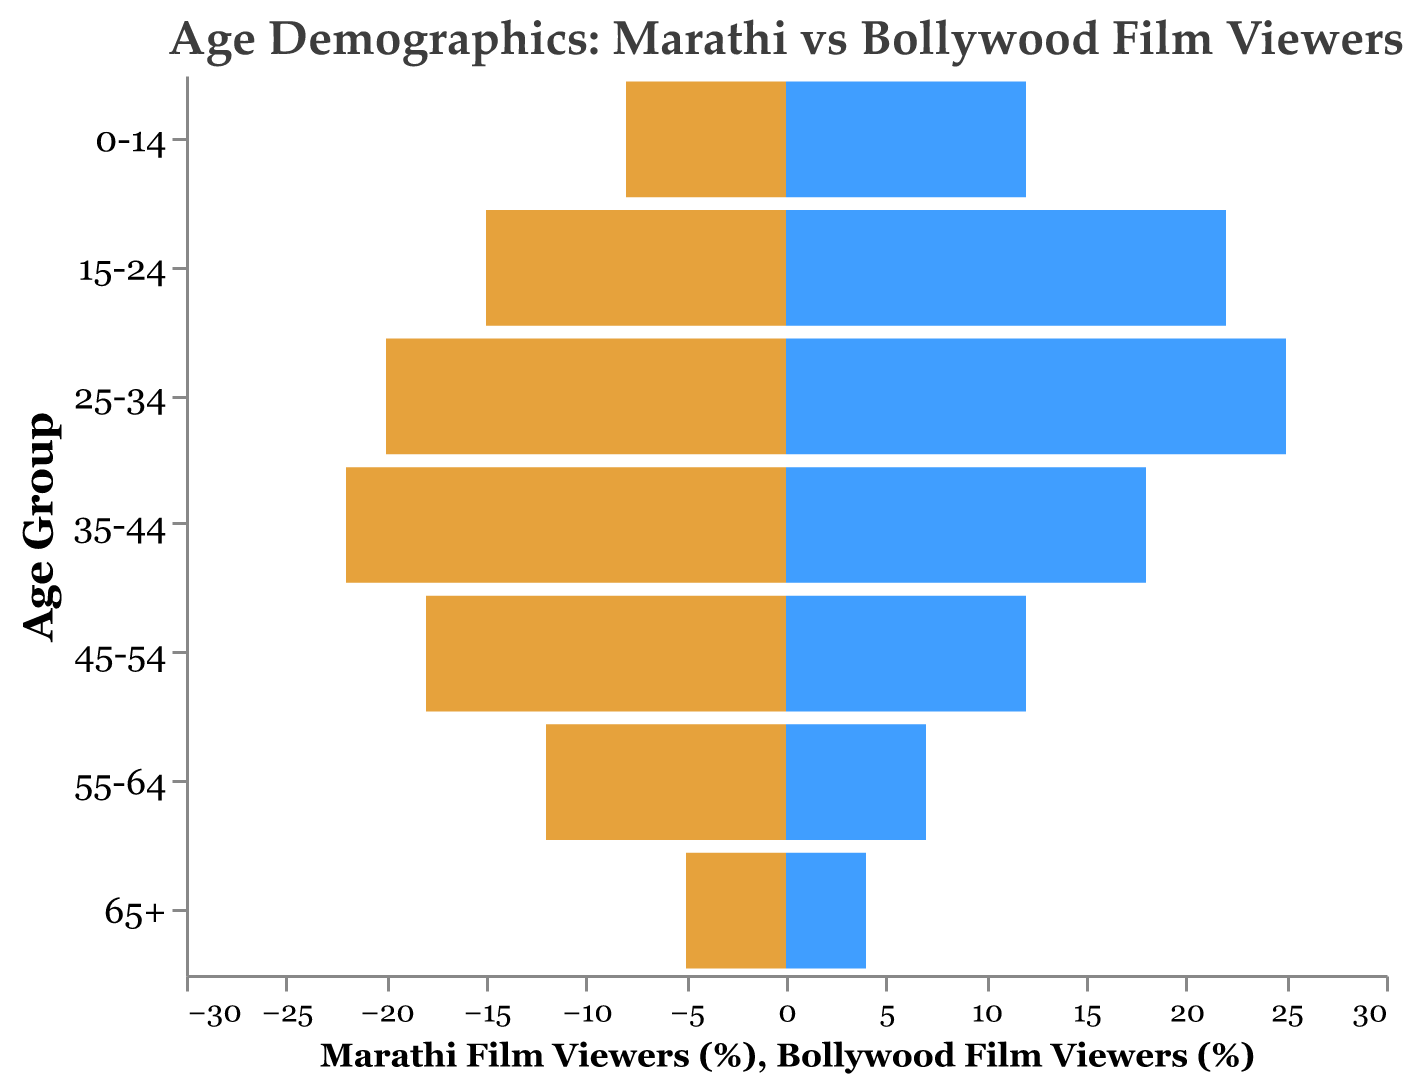What is the title of the figure? The title of the figure is displayed prominently at the top, indicating the comparison of age demographics between Marathi and Bollywood film viewers.
Answer: Age Demographics: Marathi vs Bollywood Film Viewers Which age group has the highest percentage of Marathi film viewers? Look for the largest bar on the left side, representing Marathi film viewers. The group with the largest absolute value on this side is the 35-44 age group.
Answer: 35-44 Which age group has the lowest percentage of Bollywood film viewers? Find the smallest bar on the right side, representing Bollywood film viewers. The smallest bar corresponds to the 65+ age group.
Answer: 65+ How does the percentage of viewers in the 0-14 age group compare between Marathi and Bollywood films? Compare the bars for the 0-14 age group on both sides. The Bollywood bar (right side) is longer than the Marathi bar (left side).
Answer: Bollywood has a higher percentage (12% vs 8%) Which age group shows a higher percentage of Marathi film viewers compared to Bollywood film viewers? Look for age groups where the left-side bar (Marathi) is longer than the right-side bar (Bollywood). The groups 35-44, 45-54, 55-64, and 65+ fulfill this criterion.
Answer: 35-44, 45-54, 55-64, and 65+ What is the percentage difference of viewers in the 25-34 age group between Marathi and Bollywood films? Subtract the percentage of Marathi (20%) from Bollywood (25%) viewers. The difference is 25% - 20% = 5%.
Answer: 5% In which age group is the difference in viewer percentages between Marathi and Bollywood films the greatest? Compare the percentage differences across all age groups. The 15-24 age group has a difference of 7% (22% Bollywood - 15% Marathi), which is the highest observed.
Answer: 15-24 What age group makes up about 12% of Bollywood film viewers? Find the bar on the right side that aligns with 12%. The groups that match this are 45-54.
Answer: 45-54 How do the percentages of viewers aged 55-64 differ between Marathi and Bollywood films? Look at the bars for the 55-64 age group. Marathi viewers are at 12%, while Bollywood viewers are at 7%. Calculate the difference: 12% - 7% = 5%.
Answer: Marathi has 5% more viewers Which age groups constitute the smallest audience segments for both Marathi and Bollywood films? Find the age group with the smallest bars on both sides. Both 65+ categories (5% for Marathi and 4% for Bollywood) are the smallest.
Answer: 65+ 